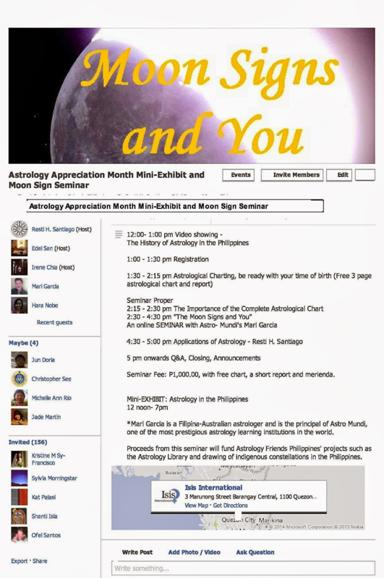What is the event mentioned in the text? The event is the Astrology Appreciation Month Mini-Exhibit and Moon Sign Seminar, which includes a range of activities centered around the appreciation and understanding of astrology, with an emphasis on moon signs. 